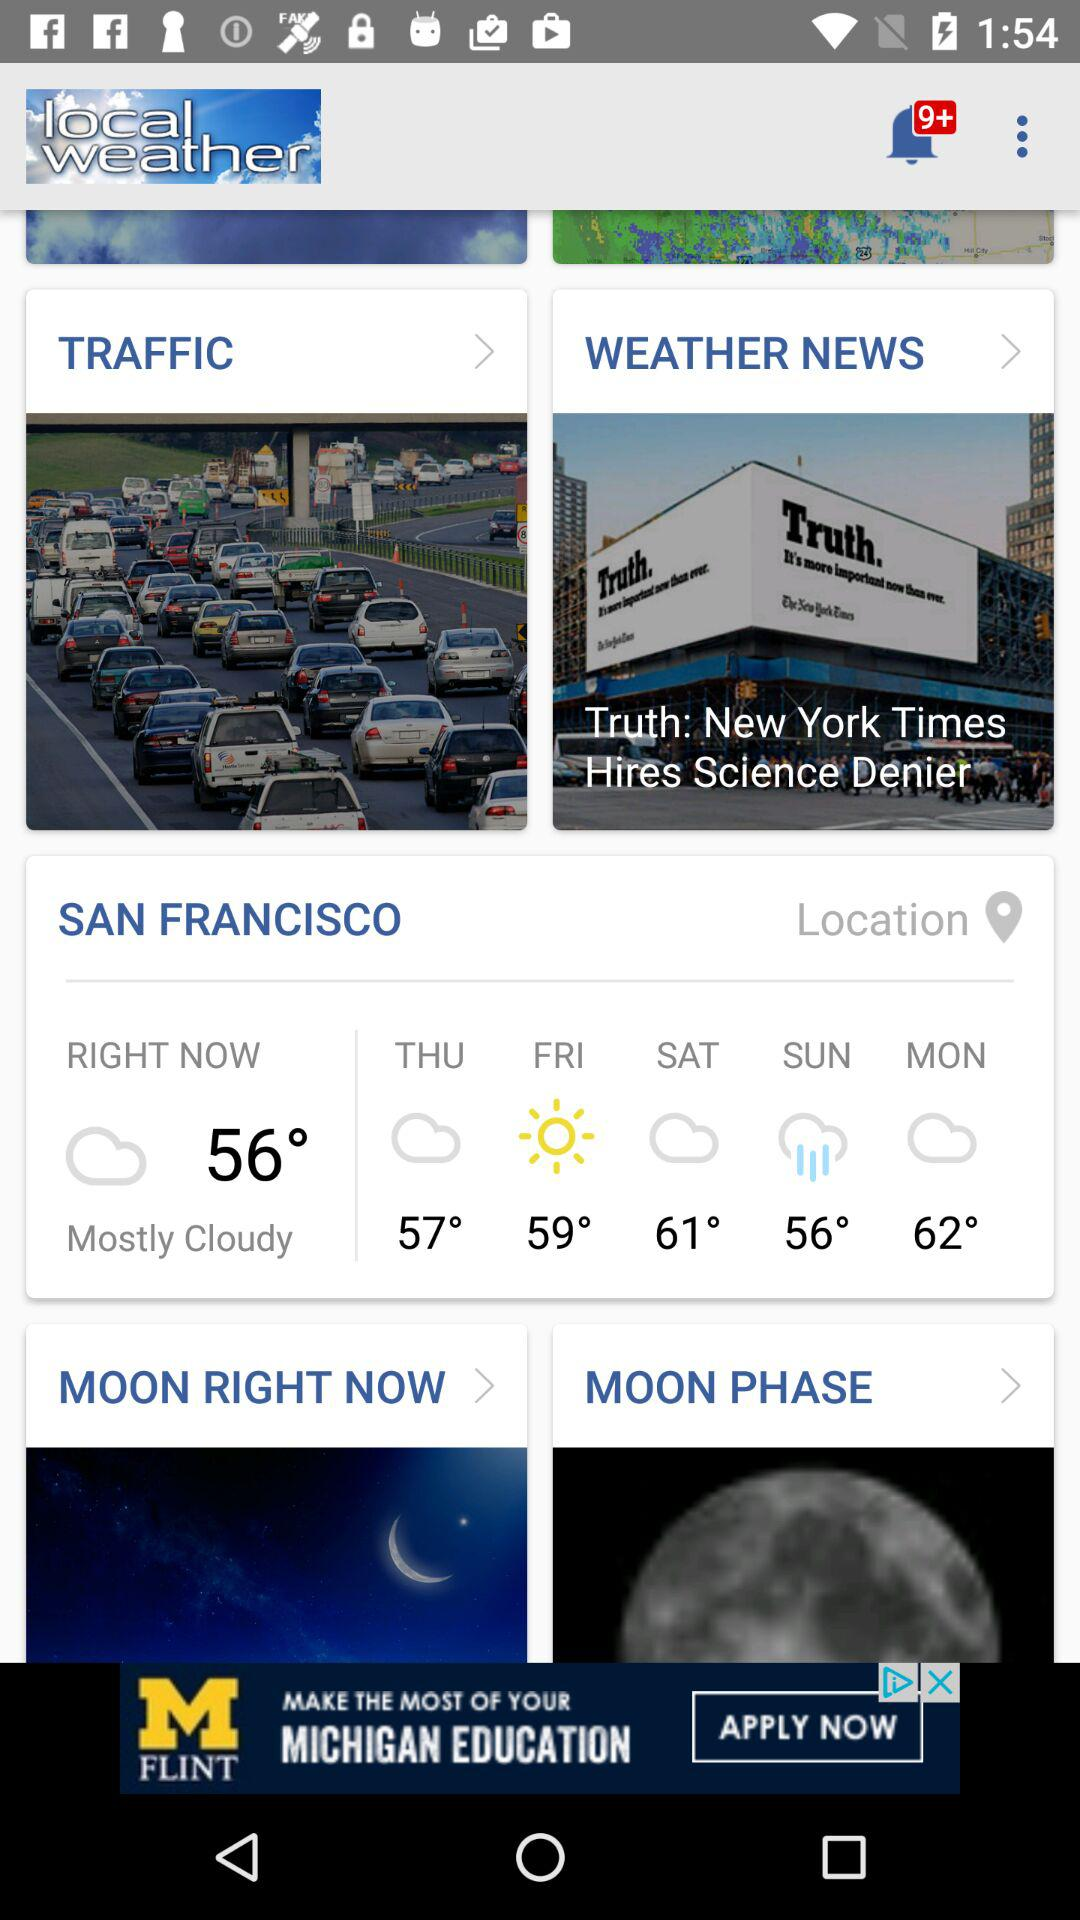How many days are in the weather forecast?
Answer the question using a single word or phrase. 5 